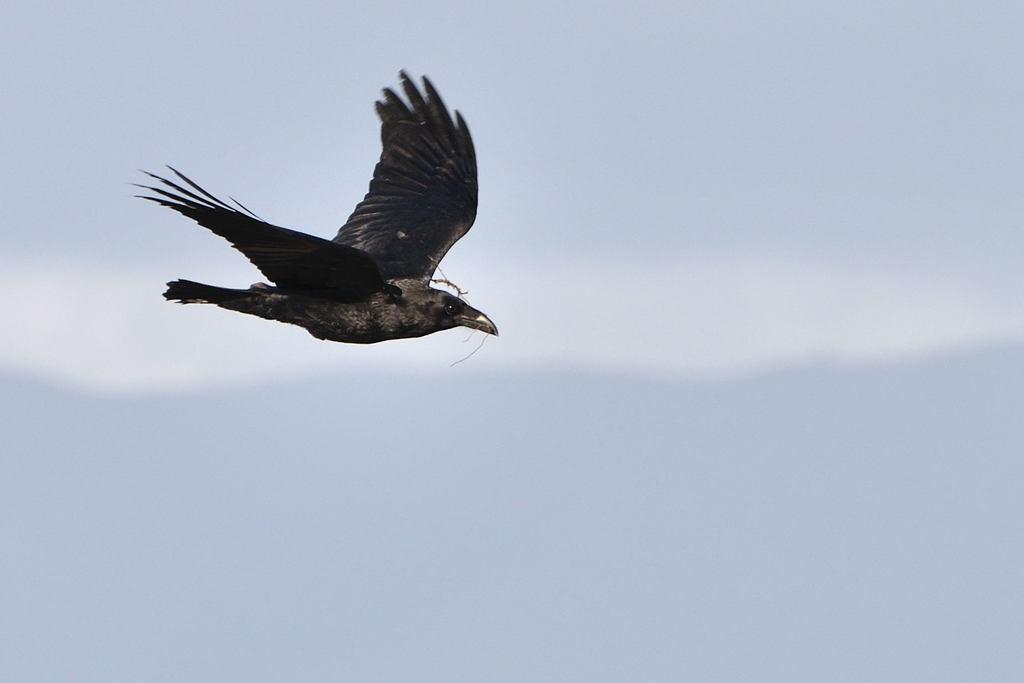Can you describe this image briefly? In this image we can see a bird flying in the sky. 